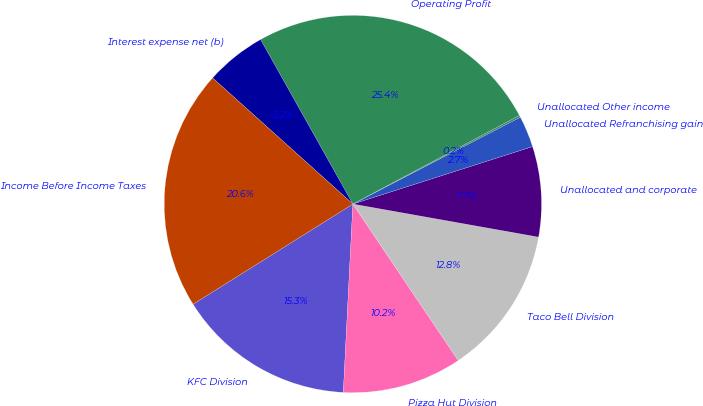<chart> <loc_0><loc_0><loc_500><loc_500><pie_chart><fcel>KFC Division<fcel>Pizza Hut Division<fcel>Taco Bell Division<fcel>Unallocated and corporate<fcel>Unallocated Refranchising gain<fcel>Unallocated Other income<fcel>Operating Profit<fcel>Interest expense net (b)<fcel>Income Before Income Taxes<nl><fcel>15.28%<fcel>10.24%<fcel>12.76%<fcel>7.73%<fcel>2.69%<fcel>0.17%<fcel>25.35%<fcel>5.21%<fcel>20.56%<nl></chart> 